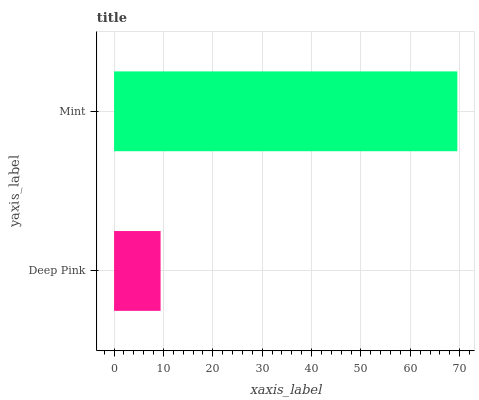Is Deep Pink the minimum?
Answer yes or no. Yes. Is Mint the maximum?
Answer yes or no. Yes. Is Mint the minimum?
Answer yes or no. No. Is Mint greater than Deep Pink?
Answer yes or no. Yes. Is Deep Pink less than Mint?
Answer yes or no. Yes. Is Deep Pink greater than Mint?
Answer yes or no. No. Is Mint less than Deep Pink?
Answer yes or no. No. Is Mint the high median?
Answer yes or no. Yes. Is Deep Pink the low median?
Answer yes or no. Yes. Is Deep Pink the high median?
Answer yes or no. No. Is Mint the low median?
Answer yes or no. No. 